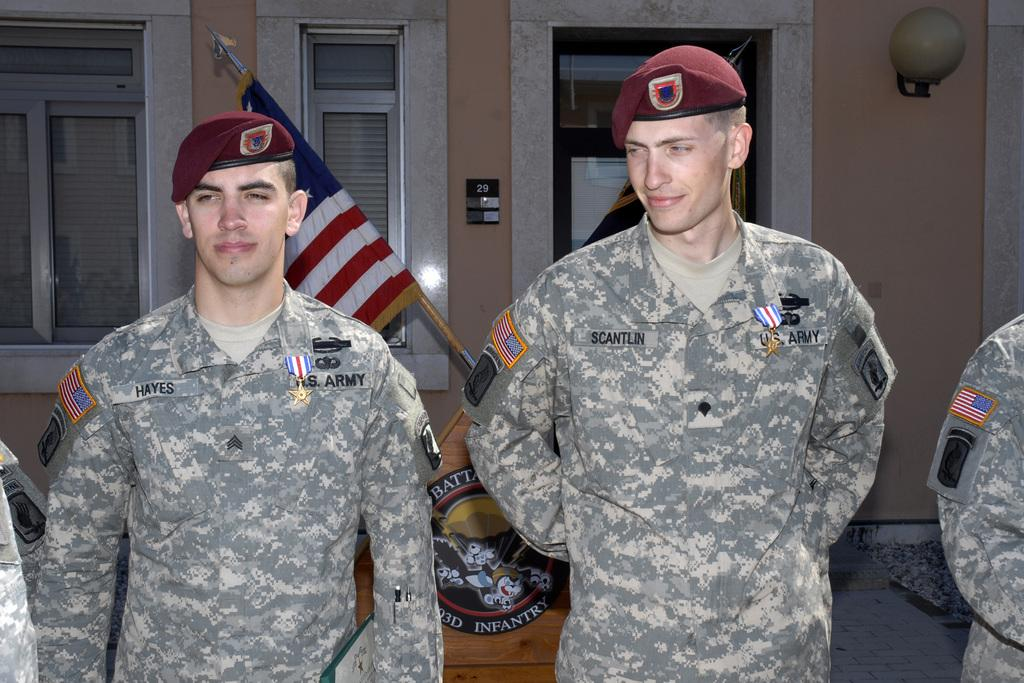<image>
Write a terse but informative summary of the picture. Military men standing in front of a podium with uniforms that state Army. 